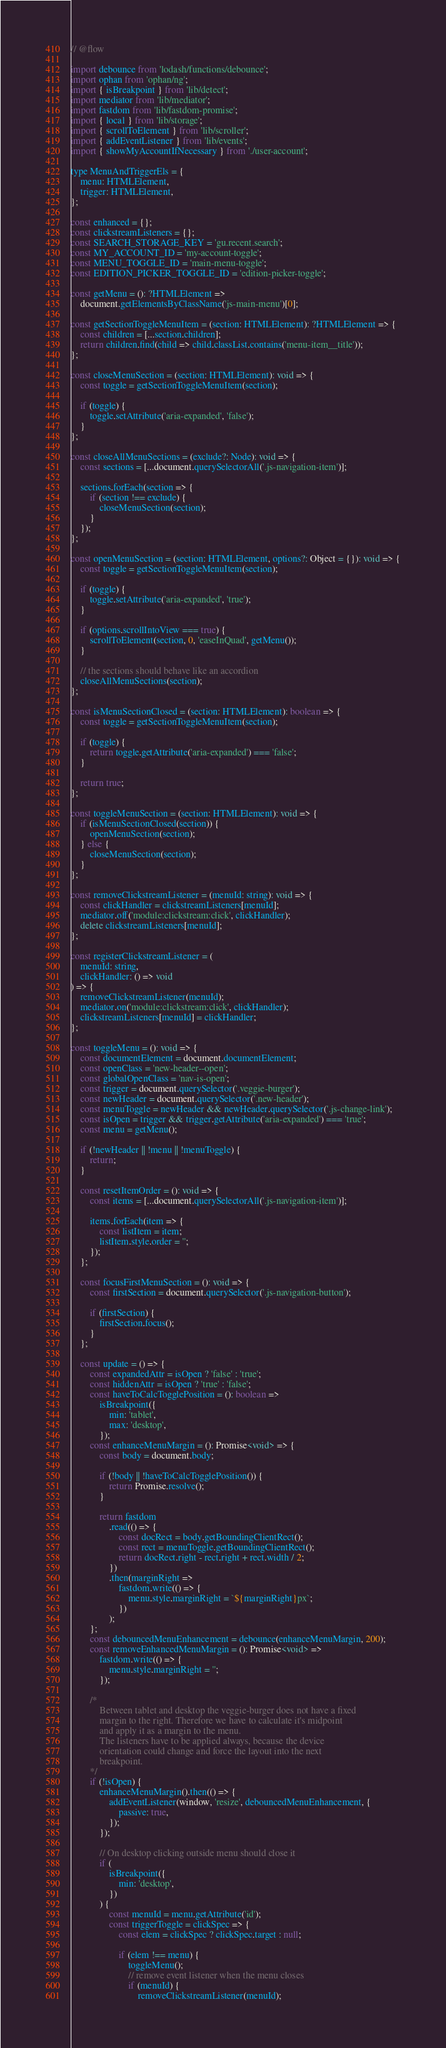Convert code to text. <code><loc_0><loc_0><loc_500><loc_500><_JavaScript_>// @flow

import debounce from 'lodash/functions/debounce';
import ophan from 'ophan/ng';
import { isBreakpoint } from 'lib/detect';
import mediator from 'lib/mediator';
import fastdom from 'lib/fastdom-promise';
import { local } from 'lib/storage';
import { scrollToElement } from 'lib/scroller';
import { addEventListener } from 'lib/events';
import { showMyAccountIfNecessary } from './user-account';

type MenuAndTriggerEls = {
    menu: HTMLElement,
    trigger: HTMLElement,
};

const enhanced = {};
const clickstreamListeners = {};
const SEARCH_STORAGE_KEY = 'gu.recent.search';
const MY_ACCOUNT_ID = 'my-account-toggle';
const MENU_TOGGLE_ID = 'main-menu-toggle';
const EDITION_PICKER_TOGGLE_ID = 'edition-picker-toggle';

const getMenu = (): ?HTMLElement =>
    document.getElementsByClassName('js-main-menu')[0];

const getSectionToggleMenuItem = (section: HTMLElement): ?HTMLElement => {
    const children = [...section.children];
    return children.find(child => child.classList.contains('menu-item__title'));
};

const closeMenuSection = (section: HTMLElement): void => {
    const toggle = getSectionToggleMenuItem(section);

    if (toggle) {
        toggle.setAttribute('aria-expanded', 'false');
    }
};

const closeAllMenuSections = (exclude?: Node): void => {
    const sections = [...document.querySelectorAll('.js-navigation-item')];

    sections.forEach(section => {
        if (section !== exclude) {
            closeMenuSection(section);
        }
    });
};

const openMenuSection = (section: HTMLElement, options?: Object = {}): void => {
    const toggle = getSectionToggleMenuItem(section);

    if (toggle) {
        toggle.setAttribute('aria-expanded', 'true');
    }

    if (options.scrollIntoView === true) {
        scrollToElement(section, 0, 'easeInQuad', getMenu());
    }

    // the sections should behave like an accordion
    closeAllMenuSections(section);
};

const isMenuSectionClosed = (section: HTMLElement): boolean => {
    const toggle = getSectionToggleMenuItem(section);

    if (toggle) {
        return toggle.getAttribute('aria-expanded') === 'false';
    }

    return true;
};

const toggleMenuSection = (section: HTMLElement): void => {
    if (isMenuSectionClosed(section)) {
        openMenuSection(section);
    } else {
        closeMenuSection(section);
    }
};

const removeClickstreamListener = (menuId: string): void => {
    const clickHandler = clickstreamListeners[menuId];
    mediator.off('module:clickstream:click', clickHandler);
    delete clickstreamListeners[menuId];
};

const registerClickstreamListener = (
    menuId: string,
    clickHandler: () => void
) => {
    removeClickstreamListener(menuId);
    mediator.on('module:clickstream:click', clickHandler);
    clickstreamListeners[menuId] = clickHandler;
};

const toggleMenu = (): void => {
    const documentElement = document.documentElement;
    const openClass = 'new-header--open';
    const globalOpenClass = 'nav-is-open';
    const trigger = document.querySelector('.veggie-burger');
    const newHeader = document.querySelector('.new-header');
    const menuToggle = newHeader && newHeader.querySelector('.js-change-link');
    const isOpen = trigger && trigger.getAttribute('aria-expanded') === 'true';
    const menu = getMenu();

    if (!newHeader || !menu || !menuToggle) {
        return;
    }

    const resetItemOrder = (): void => {
        const items = [...document.querySelectorAll('.js-navigation-item')];

        items.forEach(item => {
            const listItem = item;
            listItem.style.order = '';
        });
    };

    const focusFirstMenuSection = (): void => {
        const firstSection = document.querySelector('.js-navigation-button');

        if (firstSection) {
            firstSection.focus();
        }
    };

    const update = () => {
        const expandedAttr = isOpen ? 'false' : 'true';
        const hiddenAttr = isOpen ? 'true' : 'false';
        const haveToCalcTogglePosition = (): boolean =>
            isBreakpoint({
                min: 'tablet',
                max: 'desktop',
            });
        const enhanceMenuMargin = (): Promise<void> => {
            const body = document.body;

            if (!body || !haveToCalcTogglePosition()) {
                return Promise.resolve();
            }

            return fastdom
                .read(() => {
                    const docRect = body.getBoundingClientRect();
                    const rect = menuToggle.getBoundingClientRect();
                    return docRect.right - rect.right + rect.width / 2;
                })
                .then(marginRight =>
                    fastdom.write(() => {
                        menu.style.marginRight = `${marginRight}px`;
                    })
                );
        };
        const debouncedMenuEnhancement = debounce(enhanceMenuMargin, 200);
        const removeEnhancedMenuMargin = (): Promise<void> =>
            fastdom.write(() => {
                menu.style.marginRight = '';
            });

        /*
            Between tablet and desktop the veggie-burger does not have a fixed
            margin to the right. Therefore we have to calculate it's midpoint
            and apply it as a margin to the menu.
            The listeners have to be applied always, because the device
            orientation could change and force the layout into the next
            breakpoint.
        */
        if (!isOpen) {
            enhanceMenuMargin().then(() => {
                addEventListener(window, 'resize', debouncedMenuEnhancement, {
                    passive: true,
                });
            });

            // On desktop clicking outside menu should close it
            if (
                isBreakpoint({
                    min: 'desktop',
                })
            ) {
                const menuId = menu.getAttribute('id');
                const triggerToggle = clickSpec => {
                    const elem = clickSpec ? clickSpec.target : null;

                    if (elem !== menu) {
                        toggleMenu();
                        // remove event listener when the menu closes
                        if (menuId) {
                            removeClickstreamListener(menuId);</code> 